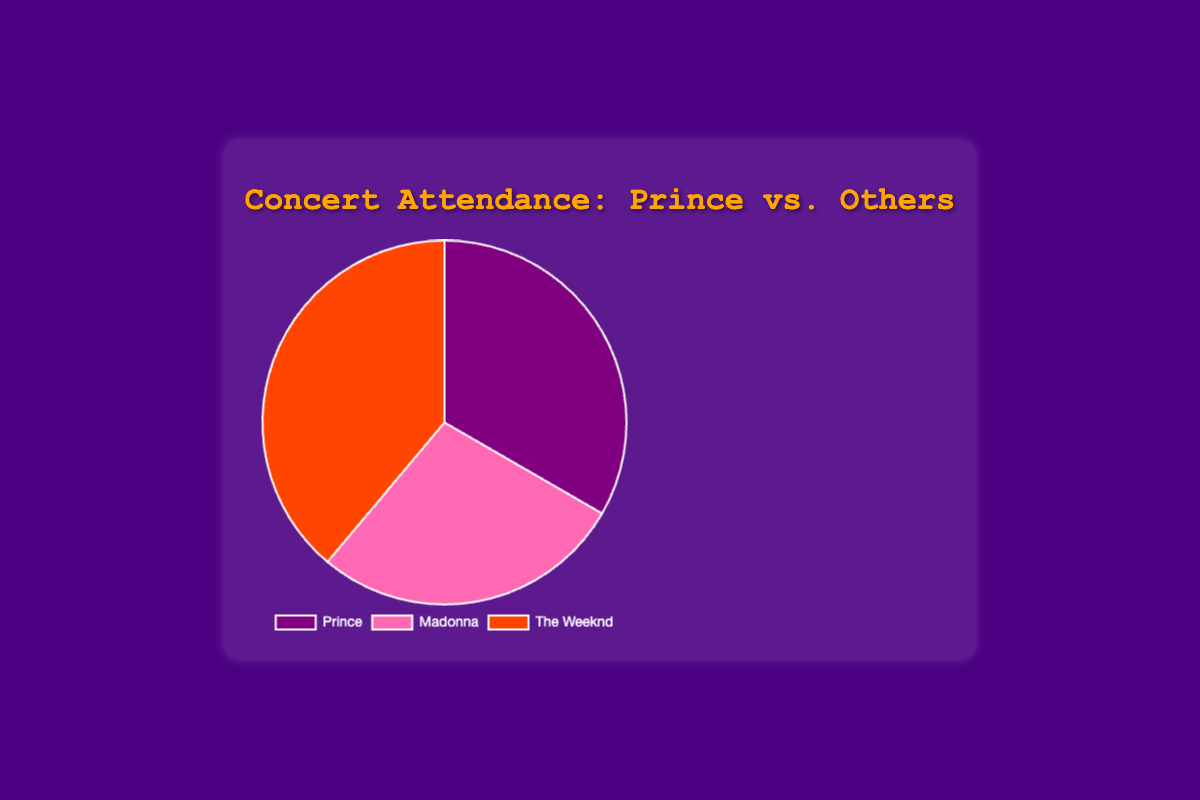What is the attendance number for Prince? The attendance number for Prince is labeled directly on the pie chart, showing 1,200,000.
Answer: 1,200,000 Which artist has the highest concert attendance? By looking at the slices of the pie chart, The Weeknd's slice is the largest, representing the highest attendance number of 1,400,000.
Answer: The Weeknd How much larger is The Weeknd’s attendance compared to Madonna’s? The Weeknd’s attendance is 1,400,000 and Madonna’s is 1,000,000. The difference is 1,400,000 - 1,000,000 = 400,000.
Answer: 400,000 What percentage of total attendance is represented by Prince? The total attendance is the sum of individual attendances: 1,200,000 (Prince) + 1,000,000 (Madonna) + 1,400,000 (The Weeknd) = 3,600,000. The percentage for Prince is (1,200,000 / 3,600,000) * 100 = 33.33%.
Answer: 33.33% Which artist has the smallest slice on the pie chart and how much is it? Madonna has the smallest slice, representing an attendance of 1,000,000.
Answer: Madonna, 1,000,000 What is the combined attendance for Prince and Madonna? Adding the attendance for Prince (1,200,000) and Madonna (1,000,000) gives a total of 1,200,000 + 1,000,000 = 2,200,000.
Answer: 2,200,000 Is Prince's concert attendance closer to Madonna's or The Weeknd's? Prince’s attendance is 1,200,000. The difference with Madonna is 1,200,000 - 1,000,000 = 200,000 and with The Weeknd is 1,400,000 - 1,200,000 = 200,000. Both differences are equal.
Answer: Both equally What colors represent each artist in the pie chart? Prince is represented by purple, Madonna by pink, and The Weeknd by orange.
Answer: Prince: purple, Madonna: pink, The Weeknd: orange What is the average attendance of the three artists? The total attendance is 3,600,000 and there are 3 artists. The average is 3,600,000 / 3 = 1,200,000.
Answer: 1,200,000 